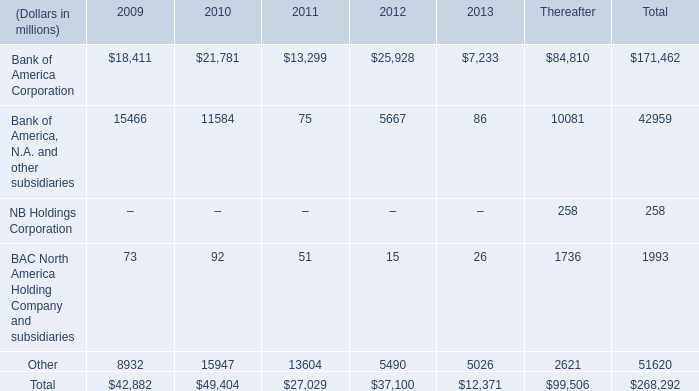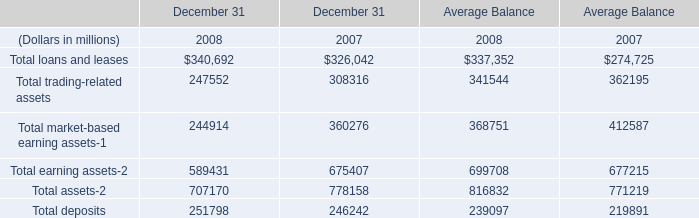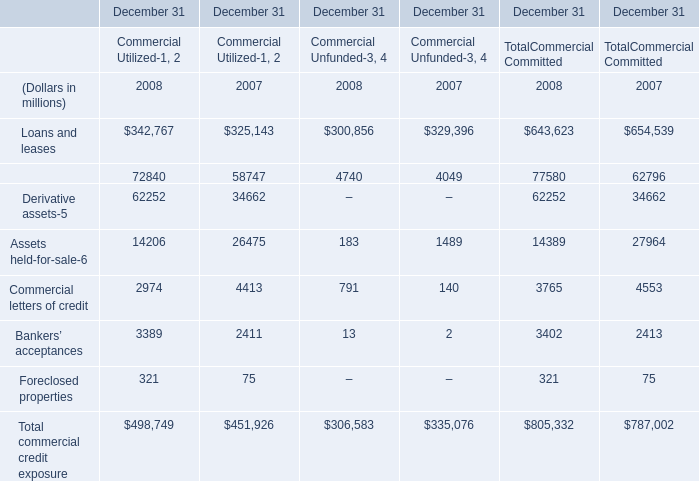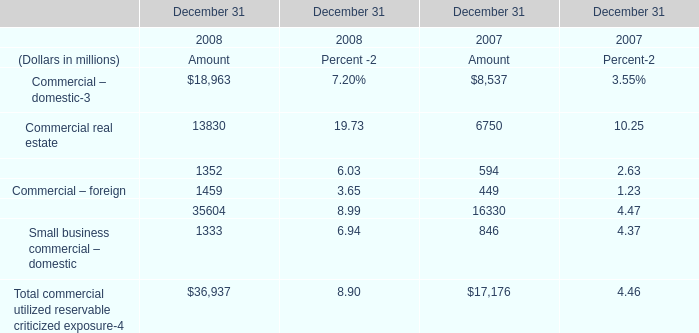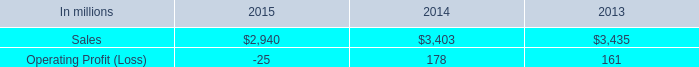In what year is Assets held-for-sale of Comercial Utilized greater than 15000? 
Answer: 2007. 